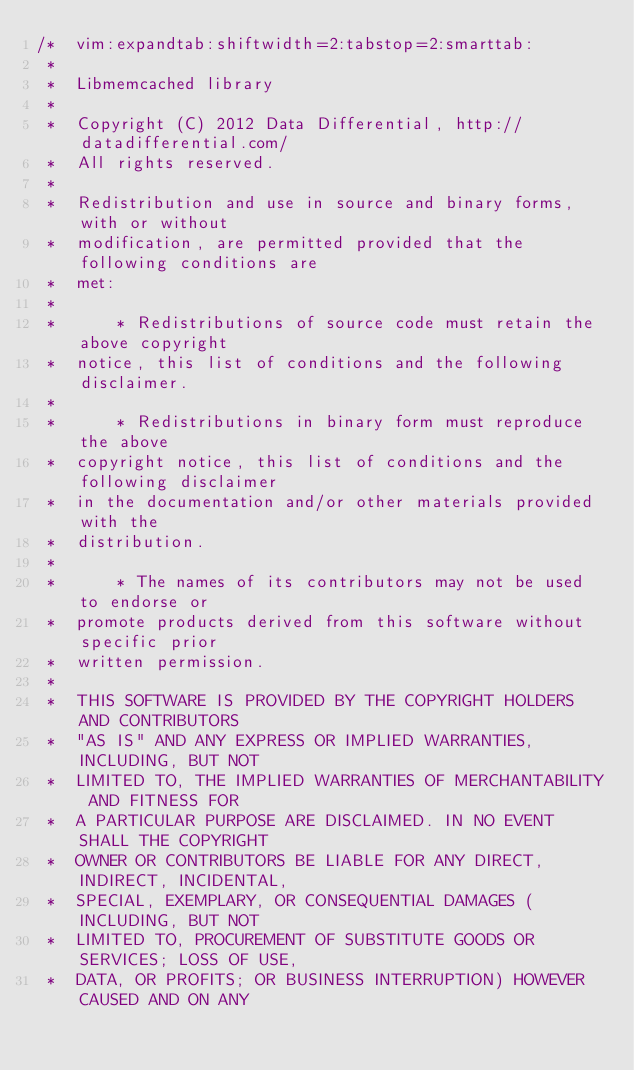Convert code to text. <code><loc_0><loc_0><loc_500><loc_500><_C++_>/*  vim:expandtab:shiftwidth=2:tabstop=2:smarttab:
 * 
 *  Libmemcached library
 *
 *  Copyright (C) 2012 Data Differential, http://datadifferential.com/ 
 *  All rights reserved.
 *
 *  Redistribution and use in source and binary forms, with or without
 *  modification, are permitted provided that the following conditions are
 *  met:
 *
 *      * Redistributions of source code must retain the above copyright
 *  notice, this list of conditions and the following disclaimer.
 *
 *      * Redistributions in binary form must reproduce the above
 *  copyright notice, this list of conditions and the following disclaimer
 *  in the documentation and/or other materials provided with the
 *  distribution.
 *
 *      * The names of its contributors may not be used to endorse or
 *  promote products derived from this software without specific prior
 *  written permission.
 *
 *  THIS SOFTWARE IS PROVIDED BY THE COPYRIGHT HOLDERS AND CONTRIBUTORS
 *  "AS IS" AND ANY EXPRESS OR IMPLIED WARRANTIES, INCLUDING, BUT NOT
 *  LIMITED TO, THE IMPLIED WARRANTIES OF MERCHANTABILITY AND FITNESS FOR
 *  A PARTICULAR PURPOSE ARE DISCLAIMED. IN NO EVENT SHALL THE COPYRIGHT
 *  OWNER OR CONTRIBUTORS BE LIABLE FOR ANY DIRECT, INDIRECT, INCIDENTAL,
 *  SPECIAL, EXEMPLARY, OR CONSEQUENTIAL DAMAGES (INCLUDING, BUT NOT
 *  LIMITED TO, PROCUREMENT OF SUBSTITUTE GOODS OR SERVICES; LOSS OF USE,
 *  DATA, OR PROFITS; OR BUSINESS INTERRUPTION) HOWEVER CAUSED AND ON ANY</code> 